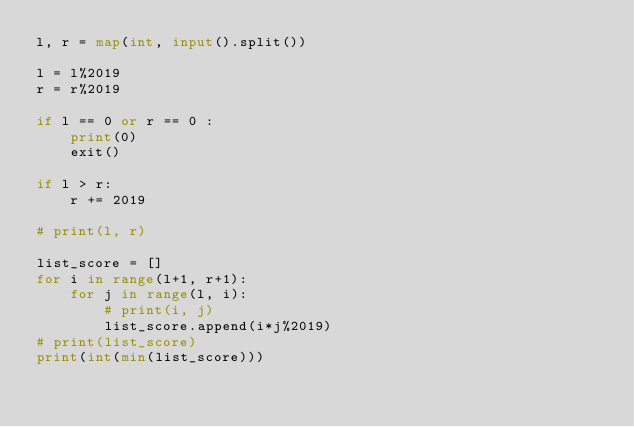Convert code to text. <code><loc_0><loc_0><loc_500><loc_500><_Python_>l, r = map(int, input().split())

l = l%2019
r = r%2019

if l == 0 or r == 0 :
    print(0)
    exit()

if l > r:
    r += 2019

# print(l, r)

list_score = []
for i in range(l+1, r+1):
    for j in range(l, i):
        # print(i, j)
        list_score.append(i*j%2019)
# print(list_score)
print(int(min(list_score)))</code> 